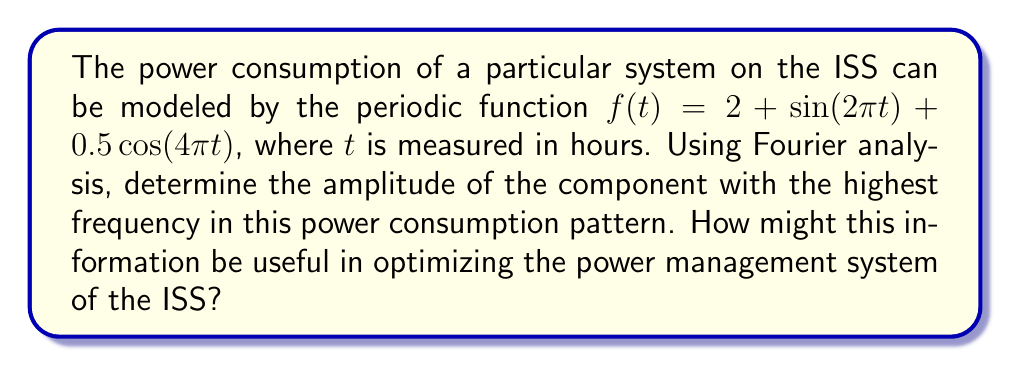Give your solution to this math problem. To solve this problem, we need to analyze the given function using Fourier transform principles. Let's break it down step-by-step:

1) The given function is:
   $$f(t) = 2 + \sin(2\pi t) + 0.5\cos(4\pi t)$$

2) This function is already expressed in terms of sinusoidal components, which makes our analysis easier. We can identify three components:

   a) A constant term: $2$
   b) A sine term: $\sin(2\pi t)$
   c) A cosine term: $0.5\cos(4\pi t)$

3) In terms of frequency:
   - The constant term has a frequency of 0 Hz
   - The sine term has a frequency of 1 Hz (as $2\pi$ radians = 1 cycle)
   - The cosine term has a frequency of 2 Hz (as $4\pi$ radians = 2 cycles)

4) The amplitudes of these components are:
   - Constant term: 2
   - Sine term: 1
   - Cosine term: 0.5

5) The component with the highest frequency is the cosine term with 2 Hz.

6) The amplitude of this highest frequency component is 0.5.

This information can be useful in optimizing the power management system of the ISS in several ways:

1) It helps in understanding the cyclic nature of power consumption, which can be used to predict peak power demands.

2) The highest frequency component often represents rapid fluctuations in power consumption. Knowing its amplitude helps in designing power stabilization systems.

3) By identifying the dominant frequencies in power consumption, engineers can design more efficient power distribution systems that can handle these specific frequencies.

4) This analysis can be used to optimize battery charging cycles and solar panel orientation to match the power consumption patterns.
Answer: The amplitude of the component with the highest frequency is 0.5. 